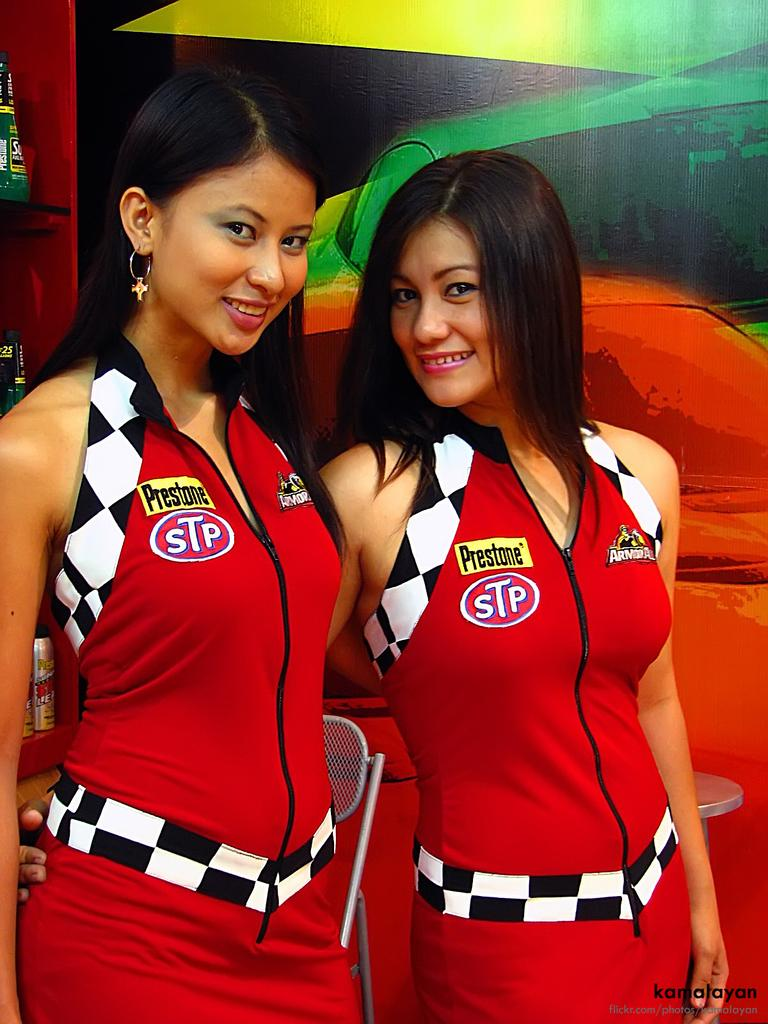<image>
Give a short and clear explanation of the subsequent image. Two female models with Prestone advertisements on their dresses 